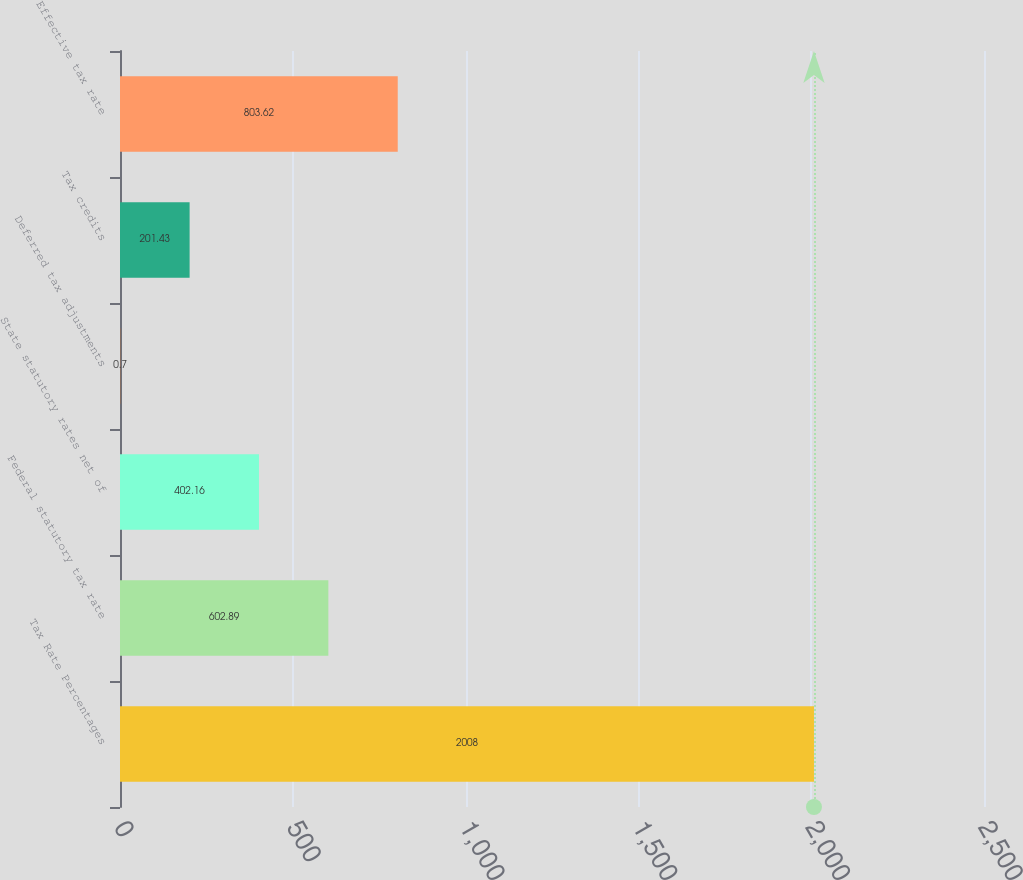<chart> <loc_0><loc_0><loc_500><loc_500><bar_chart><fcel>Tax Rate Percentages<fcel>Federal statutory tax rate<fcel>State statutory rates net of<fcel>Deferred tax adjustments<fcel>Tax credits<fcel>Effective tax rate<nl><fcel>2008<fcel>602.89<fcel>402.16<fcel>0.7<fcel>201.43<fcel>803.62<nl></chart> 